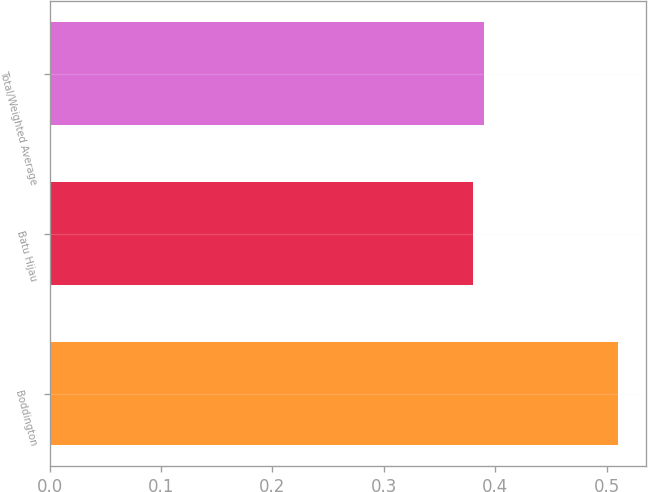Convert chart to OTSL. <chart><loc_0><loc_0><loc_500><loc_500><bar_chart><fcel>Boddington<fcel>Batu Hijau<fcel>Total/Weighted Average<nl><fcel>0.51<fcel>0.38<fcel>0.39<nl></chart> 